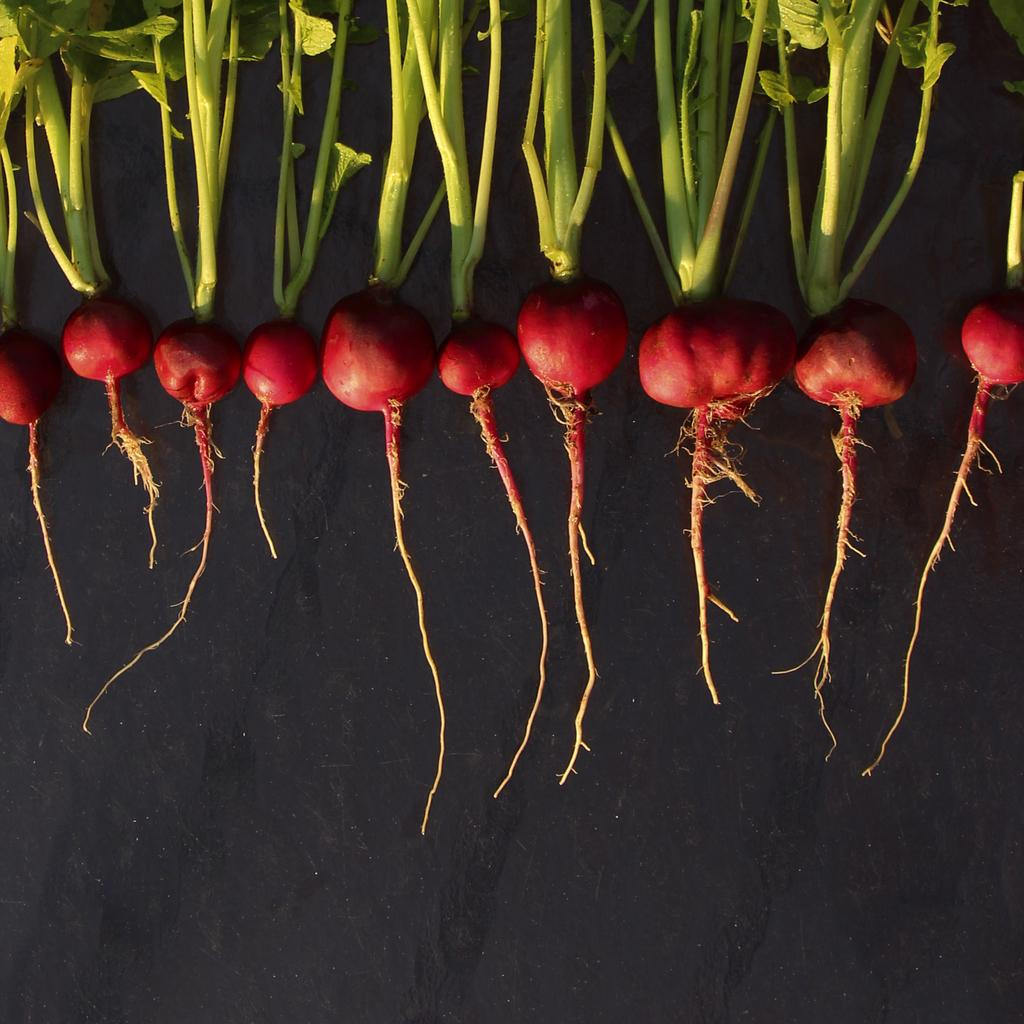What type of vegetable is present in the image? There are beetroots in the image. What parts of the beetroots are visible in the image? The beetroots have stems, leaves, and roots in the image. What is the color of the surface on which the beetroots are placed? The surface on which the beetroots are placed is black. How many rings are visible on the beetroots in the image? There are no rings visible on the beetroots in the image. What type of system is being used to grow the beetroots in the image? There is no system visible in the image; it only shows beetroots with their stems, leaves, and roots. 